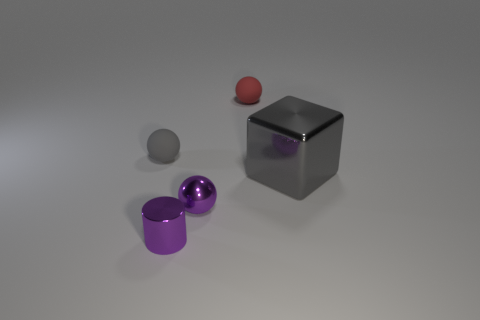Is there anything else that is the same size as the gray shiny object?
Your response must be concise. No. What number of other purple objects are the same shape as the big thing?
Offer a very short reply. 0. There is a rubber sphere that is the same size as the red rubber object; what color is it?
Your answer should be very brief. Gray. Are there the same number of small red rubber balls that are behind the small gray object and tiny rubber objects that are left of the red object?
Keep it short and to the point. Yes. Are there any gray matte things that have the same size as the cylinder?
Your answer should be compact. Yes. What is the size of the cube?
Make the answer very short. Large. Are there the same number of large gray metal blocks behind the big gray block and tiny metal cylinders?
Ensure brevity in your answer.  No. What number of other things are the same color as the small shiny ball?
Give a very brief answer. 1. What is the color of the thing that is behind the gray shiny object and on the left side of the tiny metallic ball?
Your response must be concise. Gray. There is a gray thing that is to the right of the tiny purple metal cylinder to the right of the small matte object to the left of the tiny red sphere; how big is it?
Offer a very short reply. Large. 